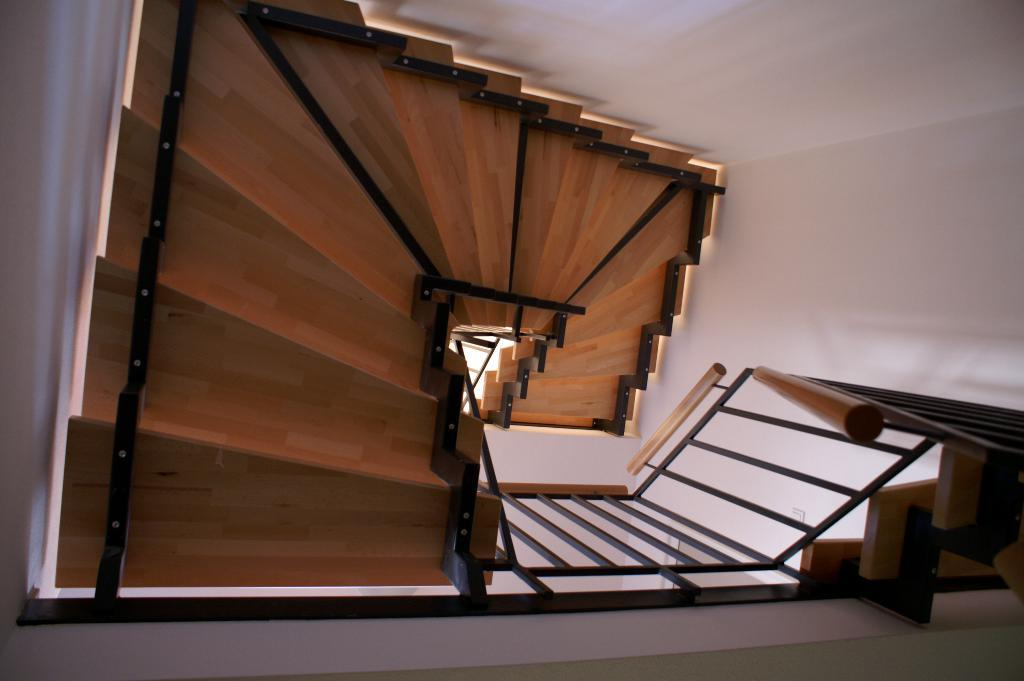What type of architectural feature is present in the image? There are steps in the image. What safety feature is included with the steps? The steps have railings. What structures are on either side of the steps? There is a wall on each side of the steps. What thought is the house having in the image? There is no house present in the image, and therefore no thoughts can be attributed to it. 